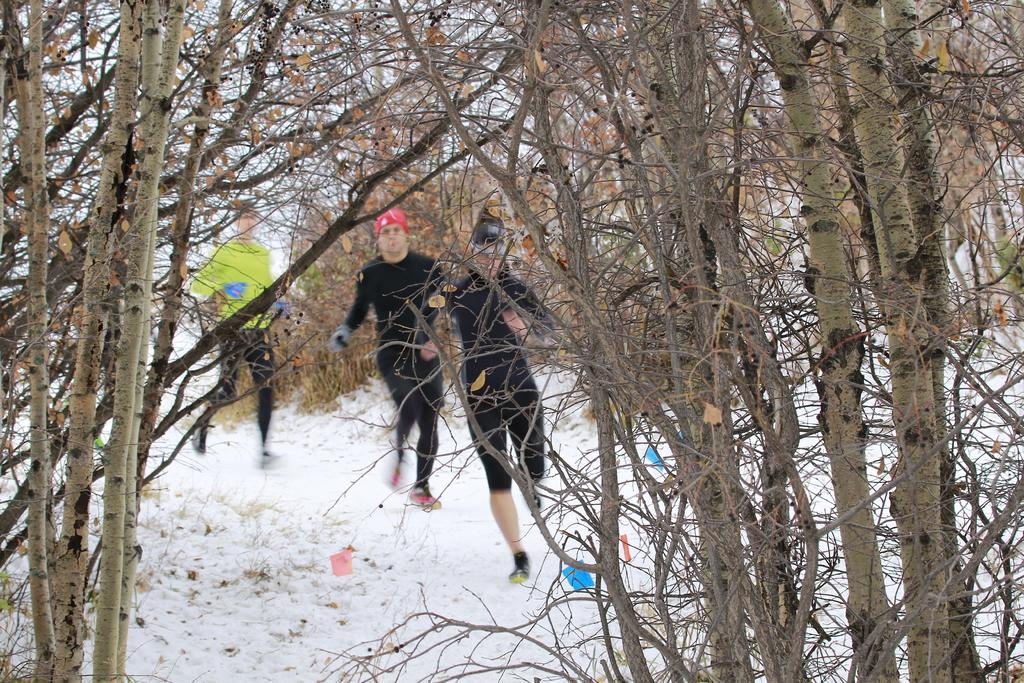How many people are in the image? There are three people in the image. What are the people wearing on their heads? The people are wearing caps. What type of footwear are the people wearing? The people are wearing shoes. What can be seen in the background of the image? There are tree branches visible in the image. What is the weather like in the image? There is snow in the image, indicating a cold or wintery environment. What type of fowl can be seen flying in the image? There is no fowl visible in the image; it only features three people and tree branches. What disease is the person in the middle of the image suffering from? There is no indication of any disease in the image; it only shows three people wearing caps, shoes, and clothes. 